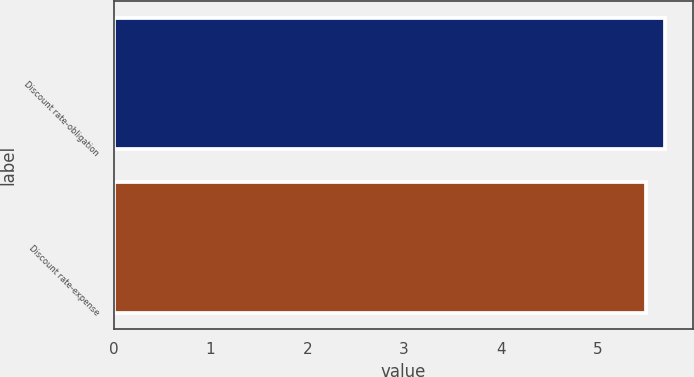Convert chart. <chart><loc_0><loc_0><loc_500><loc_500><bar_chart><fcel>Discount rate-obligation<fcel>Discount rate-expense<nl><fcel>5.7<fcel>5.5<nl></chart> 